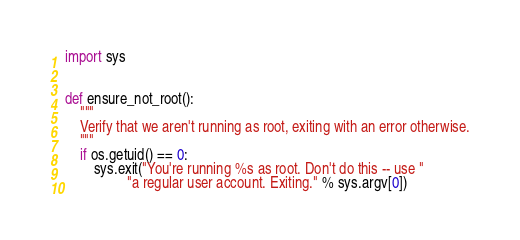<code> <loc_0><loc_0><loc_500><loc_500><_Python_>import sys


def ensure_not_root():
    """
    Verify that we aren't running as root, exiting with an error otherwise.
    """
    if os.getuid() == 0:
        sys.exit("You're running %s as root. Don't do this -- use "
                 "a regular user account. Exiting." % sys.argv[0])
</code> 